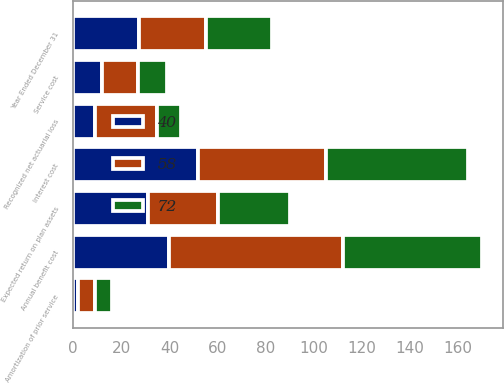<chart> <loc_0><loc_0><loc_500><loc_500><stacked_bar_chart><ecel><fcel>Year Ended December 31<fcel>Service cost<fcel>Interest cost<fcel>Expected return on plan assets<fcel>Recognized net actuarial loss<fcel>Amortization of prior service<fcel>Annual benefit cost<nl><fcel>40<fcel>27.5<fcel>12<fcel>52<fcel>31<fcel>9<fcel>2<fcel>40<nl><fcel>58<fcel>27.5<fcel>15<fcel>53<fcel>29<fcel>26<fcel>7<fcel>72<nl><fcel>72<fcel>27.5<fcel>12<fcel>59<fcel>30<fcel>10<fcel>7<fcel>58<nl></chart> 